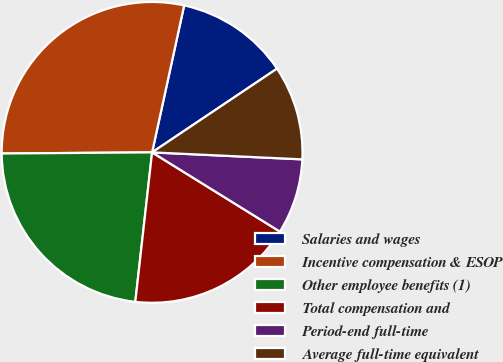Convert chart. <chart><loc_0><loc_0><loc_500><loc_500><pie_chart><fcel>Salaries and wages<fcel>Incentive compensation & ESOP<fcel>Other employee benefits (1)<fcel>Total compensation and<fcel>Period-end full-time<fcel>Average full-time equivalent<nl><fcel>12.18%<fcel>28.54%<fcel>23.1%<fcel>17.95%<fcel>8.09%<fcel>10.14%<nl></chart> 